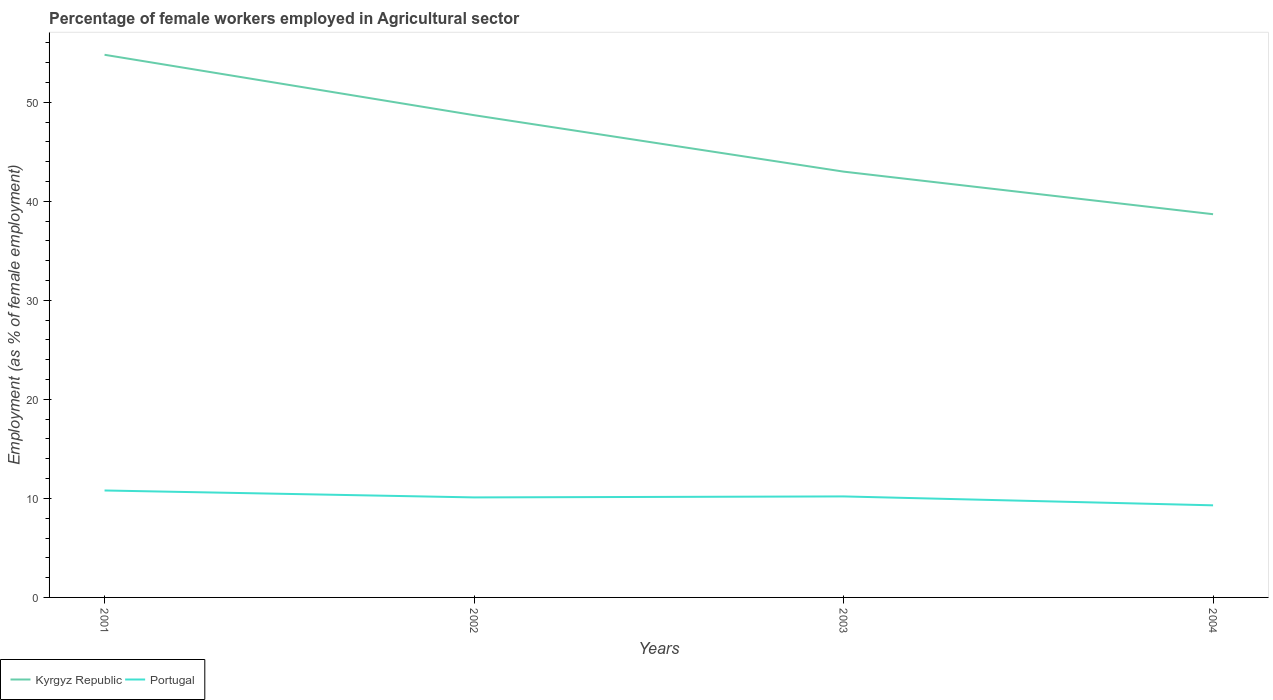How many different coloured lines are there?
Offer a very short reply. 2. Is the number of lines equal to the number of legend labels?
Your response must be concise. Yes. Across all years, what is the maximum percentage of females employed in Agricultural sector in Kyrgyz Republic?
Your response must be concise. 38.7. In which year was the percentage of females employed in Agricultural sector in Portugal maximum?
Your response must be concise. 2004. What is the total percentage of females employed in Agricultural sector in Portugal in the graph?
Provide a succinct answer. 0.6. What is the difference between the highest and the second highest percentage of females employed in Agricultural sector in Portugal?
Offer a very short reply. 1.5. What is the difference between the highest and the lowest percentage of females employed in Agricultural sector in Portugal?
Provide a short and direct response. 3. Is the percentage of females employed in Agricultural sector in Portugal strictly greater than the percentage of females employed in Agricultural sector in Kyrgyz Republic over the years?
Provide a succinct answer. Yes. What is the difference between two consecutive major ticks on the Y-axis?
Your answer should be compact. 10. Are the values on the major ticks of Y-axis written in scientific E-notation?
Your answer should be very brief. No. Does the graph contain grids?
Give a very brief answer. No. How are the legend labels stacked?
Offer a very short reply. Horizontal. What is the title of the graph?
Provide a succinct answer. Percentage of female workers employed in Agricultural sector. What is the label or title of the X-axis?
Ensure brevity in your answer.  Years. What is the label or title of the Y-axis?
Give a very brief answer. Employment (as % of female employment). What is the Employment (as % of female employment) in Kyrgyz Republic in 2001?
Provide a succinct answer. 54.8. What is the Employment (as % of female employment) in Portugal in 2001?
Provide a short and direct response. 10.8. What is the Employment (as % of female employment) in Kyrgyz Republic in 2002?
Offer a very short reply. 48.7. What is the Employment (as % of female employment) of Portugal in 2002?
Your answer should be compact. 10.1. What is the Employment (as % of female employment) of Kyrgyz Republic in 2003?
Make the answer very short. 43. What is the Employment (as % of female employment) in Portugal in 2003?
Make the answer very short. 10.2. What is the Employment (as % of female employment) in Kyrgyz Republic in 2004?
Ensure brevity in your answer.  38.7. What is the Employment (as % of female employment) in Portugal in 2004?
Offer a terse response. 9.3. Across all years, what is the maximum Employment (as % of female employment) of Kyrgyz Republic?
Your answer should be compact. 54.8. Across all years, what is the maximum Employment (as % of female employment) in Portugal?
Make the answer very short. 10.8. Across all years, what is the minimum Employment (as % of female employment) of Kyrgyz Republic?
Provide a succinct answer. 38.7. Across all years, what is the minimum Employment (as % of female employment) in Portugal?
Offer a very short reply. 9.3. What is the total Employment (as % of female employment) of Kyrgyz Republic in the graph?
Your answer should be very brief. 185.2. What is the total Employment (as % of female employment) in Portugal in the graph?
Your answer should be compact. 40.4. What is the difference between the Employment (as % of female employment) in Portugal in 2001 and that in 2002?
Keep it short and to the point. 0.7. What is the difference between the Employment (as % of female employment) of Portugal in 2001 and that in 2004?
Offer a terse response. 1.5. What is the difference between the Employment (as % of female employment) of Kyrgyz Republic in 2002 and that in 2003?
Your answer should be compact. 5.7. What is the difference between the Employment (as % of female employment) in Portugal in 2002 and that in 2004?
Your answer should be compact. 0.8. What is the difference between the Employment (as % of female employment) in Kyrgyz Republic in 2003 and that in 2004?
Ensure brevity in your answer.  4.3. What is the difference between the Employment (as % of female employment) of Kyrgyz Republic in 2001 and the Employment (as % of female employment) of Portugal in 2002?
Keep it short and to the point. 44.7. What is the difference between the Employment (as % of female employment) of Kyrgyz Republic in 2001 and the Employment (as % of female employment) of Portugal in 2003?
Provide a short and direct response. 44.6. What is the difference between the Employment (as % of female employment) in Kyrgyz Republic in 2001 and the Employment (as % of female employment) in Portugal in 2004?
Provide a succinct answer. 45.5. What is the difference between the Employment (as % of female employment) in Kyrgyz Republic in 2002 and the Employment (as % of female employment) in Portugal in 2003?
Provide a succinct answer. 38.5. What is the difference between the Employment (as % of female employment) in Kyrgyz Republic in 2002 and the Employment (as % of female employment) in Portugal in 2004?
Your answer should be compact. 39.4. What is the difference between the Employment (as % of female employment) of Kyrgyz Republic in 2003 and the Employment (as % of female employment) of Portugal in 2004?
Your answer should be compact. 33.7. What is the average Employment (as % of female employment) in Kyrgyz Republic per year?
Your answer should be very brief. 46.3. What is the average Employment (as % of female employment) in Portugal per year?
Your answer should be very brief. 10.1. In the year 2001, what is the difference between the Employment (as % of female employment) in Kyrgyz Republic and Employment (as % of female employment) in Portugal?
Provide a succinct answer. 44. In the year 2002, what is the difference between the Employment (as % of female employment) in Kyrgyz Republic and Employment (as % of female employment) in Portugal?
Give a very brief answer. 38.6. In the year 2003, what is the difference between the Employment (as % of female employment) of Kyrgyz Republic and Employment (as % of female employment) of Portugal?
Provide a succinct answer. 32.8. In the year 2004, what is the difference between the Employment (as % of female employment) of Kyrgyz Republic and Employment (as % of female employment) of Portugal?
Keep it short and to the point. 29.4. What is the ratio of the Employment (as % of female employment) of Kyrgyz Republic in 2001 to that in 2002?
Offer a terse response. 1.13. What is the ratio of the Employment (as % of female employment) in Portugal in 2001 to that in 2002?
Your answer should be very brief. 1.07. What is the ratio of the Employment (as % of female employment) of Kyrgyz Republic in 2001 to that in 2003?
Offer a terse response. 1.27. What is the ratio of the Employment (as % of female employment) in Portugal in 2001 to that in 2003?
Offer a very short reply. 1.06. What is the ratio of the Employment (as % of female employment) of Kyrgyz Republic in 2001 to that in 2004?
Keep it short and to the point. 1.42. What is the ratio of the Employment (as % of female employment) in Portugal in 2001 to that in 2004?
Provide a short and direct response. 1.16. What is the ratio of the Employment (as % of female employment) in Kyrgyz Republic in 2002 to that in 2003?
Your answer should be very brief. 1.13. What is the ratio of the Employment (as % of female employment) in Portugal in 2002 to that in 2003?
Ensure brevity in your answer.  0.99. What is the ratio of the Employment (as % of female employment) in Kyrgyz Republic in 2002 to that in 2004?
Offer a terse response. 1.26. What is the ratio of the Employment (as % of female employment) in Portugal in 2002 to that in 2004?
Offer a very short reply. 1.09. What is the ratio of the Employment (as % of female employment) in Portugal in 2003 to that in 2004?
Offer a very short reply. 1.1. What is the difference between the highest and the second highest Employment (as % of female employment) of Kyrgyz Republic?
Offer a very short reply. 6.1. What is the difference between the highest and the lowest Employment (as % of female employment) of Portugal?
Your answer should be compact. 1.5. 